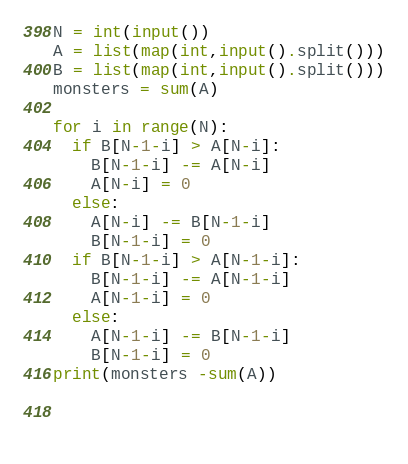Convert code to text. <code><loc_0><loc_0><loc_500><loc_500><_Python_>N = int(input())
A = list(map(int,input().split()))
B = list(map(int,input().split()))
monsters = sum(A)

for i in range(N):
  if B[N-1-i] > A[N-i]:
    B[N-1-i] -= A[N-i]
    A[N-i] = 0
  else:
    A[N-i] -= B[N-1-i]
    B[N-1-i] = 0
  if B[N-1-i] > A[N-1-i]:
    B[N-1-i] -= A[N-1-i]
    A[N-1-i] = 0
  else:
    A[N-1-i] -= B[N-1-i]
    B[N-1-i] = 0
print(monsters -sum(A))
    
    
  
</code> 